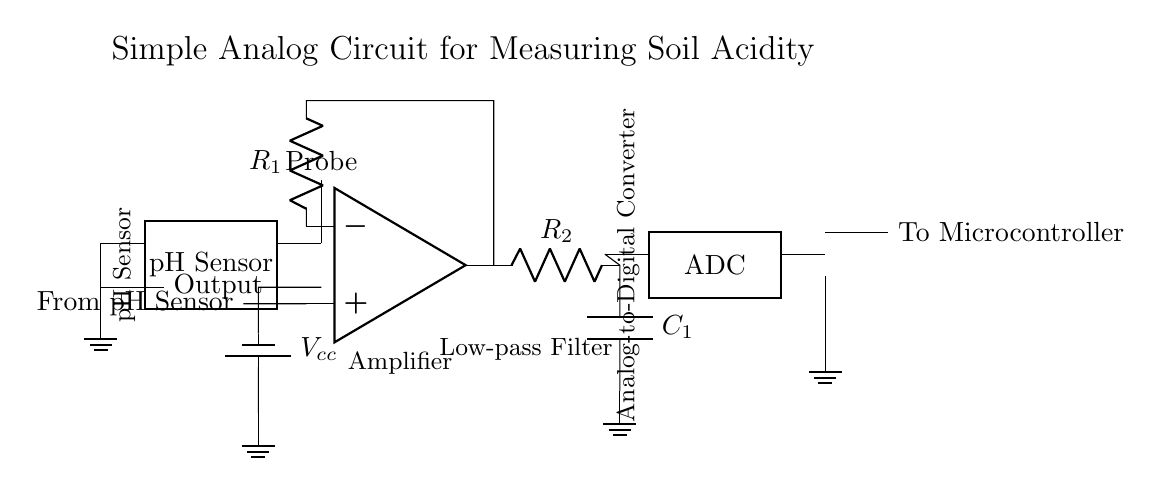What is the component used to amplify the pH sensor output? The component used for amplification in this circuit is an operational amplifier. It is represented in the diagram as a triangle symbol.
Answer: operational amplifier What is the label of the capacitor in the low-pass filter? The capacitor in the low-pass filter is labeled as C1 in the circuit. It is connected in parallel with the resistor to ground, forming the filter.
Answer: C1 What is the connection type between the pH sensor and the operational amplifier? The pH sensor output connects to the non-inverting input (+) of the operational amplifier, meaning it is a direct connection with no components in between.
Answer: direct connection What voltage does the circuit supply to the pH sensor? The circuit supplies a voltage labeled as Vcc to the pH sensor. This voltage is crucial for the proper functioning of the sensor.
Answer: Vcc What is the purpose of the low-pass filter in this circuit? The low-pass filter, which consists of a resistor (R2) and a capacitor (C1), is used to remove high-frequency noise from the signal before it is converted to a digital signal.
Answer: remove noise What does the ADC output connect to? The output of the ADC connects to the microcontroller, and it represents the digital version of the analog signal processed from the pH sensor output.
Answer: microcontroller What type of circuit is this? This circuit is classified as an analog circuit because it processes continuous signals from the pH sensor and converts them into a usable format for digital readout.
Answer: analog circuit 